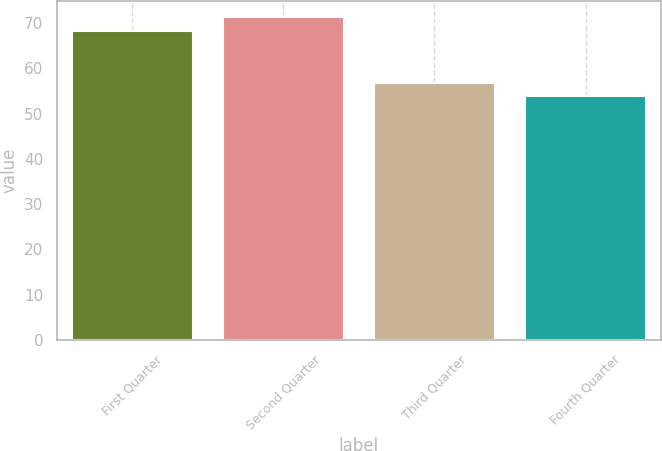<chart> <loc_0><loc_0><loc_500><loc_500><bar_chart><fcel>First Quarter<fcel>Second Quarter<fcel>Third Quarter<fcel>Fourth Quarter<nl><fcel>68.37<fcel>71.4<fcel>56.78<fcel>53.94<nl></chart> 